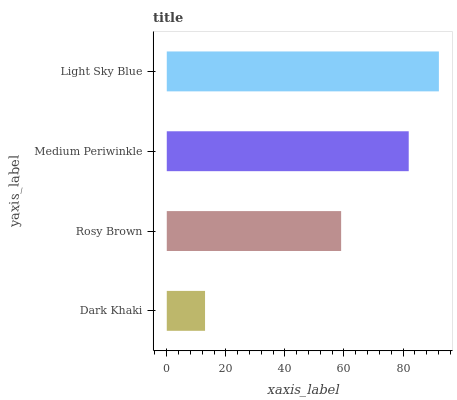Is Dark Khaki the minimum?
Answer yes or no. Yes. Is Light Sky Blue the maximum?
Answer yes or no. Yes. Is Rosy Brown the minimum?
Answer yes or no. No. Is Rosy Brown the maximum?
Answer yes or no. No. Is Rosy Brown greater than Dark Khaki?
Answer yes or no. Yes. Is Dark Khaki less than Rosy Brown?
Answer yes or no. Yes. Is Dark Khaki greater than Rosy Brown?
Answer yes or no. No. Is Rosy Brown less than Dark Khaki?
Answer yes or no. No. Is Medium Periwinkle the high median?
Answer yes or no. Yes. Is Rosy Brown the low median?
Answer yes or no. Yes. Is Dark Khaki the high median?
Answer yes or no. No. Is Dark Khaki the low median?
Answer yes or no. No. 